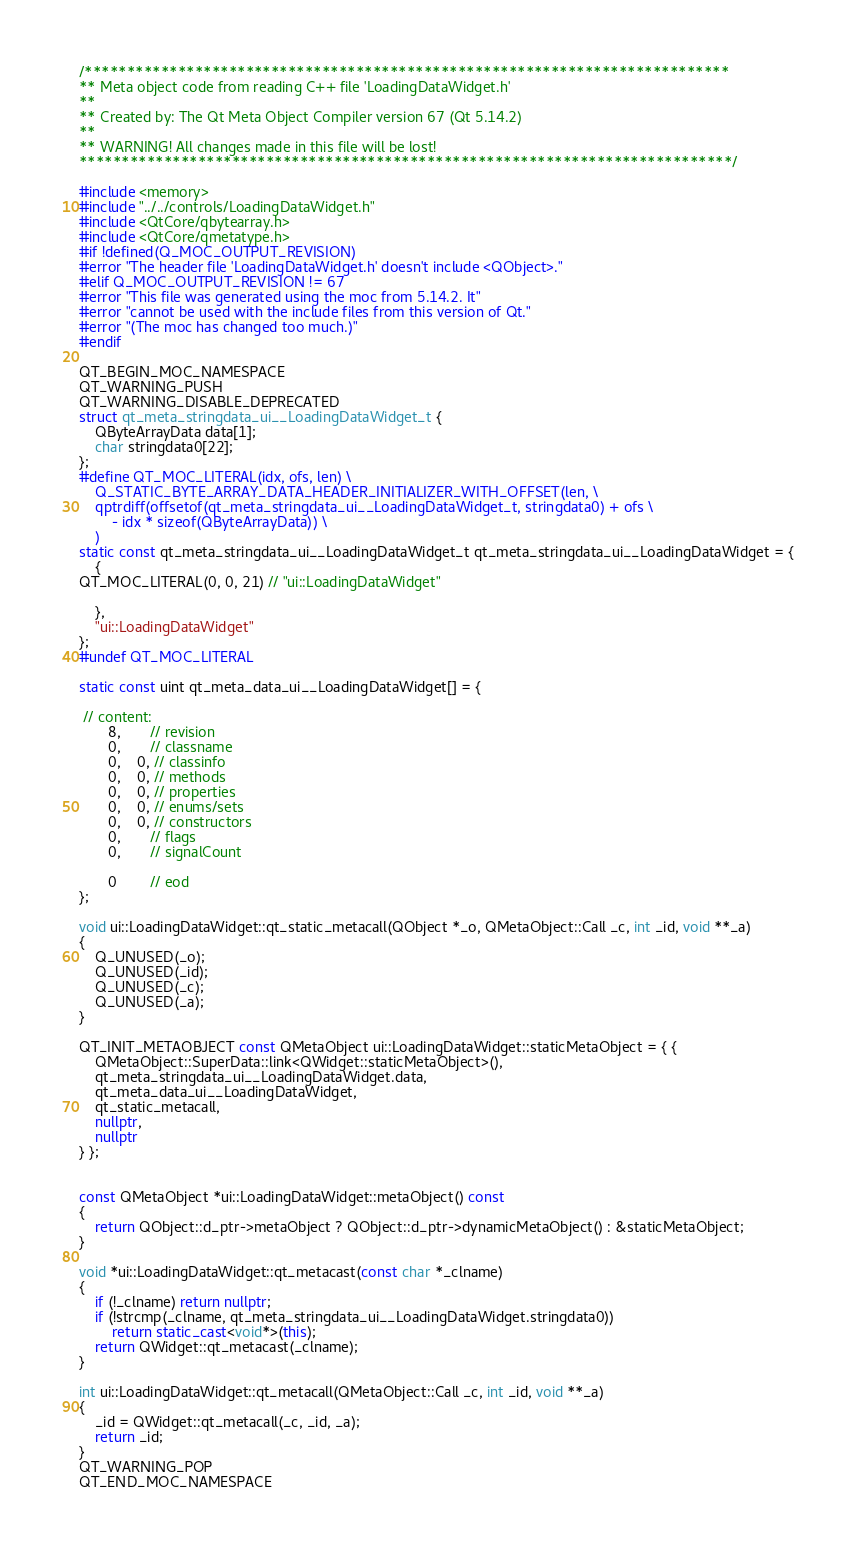Convert code to text. <code><loc_0><loc_0><loc_500><loc_500><_C++_>/****************************************************************************
** Meta object code from reading C++ file 'LoadingDataWidget.h'
**
** Created by: The Qt Meta Object Compiler version 67 (Qt 5.14.2)
**
** WARNING! All changes made in this file will be lost!
*****************************************************************************/

#include <memory>
#include "../../controls/LoadingDataWidget.h"
#include <QtCore/qbytearray.h>
#include <QtCore/qmetatype.h>
#if !defined(Q_MOC_OUTPUT_REVISION)
#error "The header file 'LoadingDataWidget.h' doesn't include <QObject>."
#elif Q_MOC_OUTPUT_REVISION != 67
#error "This file was generated using the moc from 5.14.2. It"
#error "cannot be used with the include files from this version of Qt."
#error "(The moc has changed too much.)"
#endif

QT_BEGIN_MOC_NAMESPACE
QT_WARNING_PUSH
QT_WARNING_DISABLE_DEPRECATED
struct qt_meta_stringdata_ui__LoadingDataWidget_t {
    QByteArrayData data[1];
    char stringdata0[22];
};
#define QT_MOC_LITERAL(idx, ofs, len) \
    Q_STATIC_BYTE_ARRAY_DATA_HEADER_INITIALIZER_WITH_OFFSET(len, \
    qptrdiff(offsetof(qt_meta_stringdata_ui__LoadingDataWidget_t, stringdata0) + ofs \
        - idx * sizeof(QByteArrayData)) \
    )
static const qt_meta_stringdata_ui__LoadingDataWidget_t qt_meta_stringdata_ui__LoadingDataWidget = {
    {
QT_MOC_LITERAL(0, 0, 21) // "ui::LoadingDataWidget"

    },
    "ui::LoadingDataWidget"
};
#undef QT_MOC_LITERAL

static const uint qt_meta_data_ui__LoadingDataWidget[] = {

 // content:
       8,       // revision
       0,       // classname
       0,    0, // classinfo
       0,    0, // methods
       0,    0, // properties
       0,    0, // enums/sets
       0,    0, // constructors
       0,       // flags
       0,       // signalCount

       0        // eod
};

void ui::LoadingDataWidget::qt_static_metacall(QObject *_o, QMetaObject::Call _c, int _id, void **_a)
{
    Q_UNUSED(_o);
    Q_UNUSED(_id);
    Q_UNUSED(_c);
    Q_UNUSED(_a);
}

QT_INIT_METAOBJECT const QMetaObject ui::LoadingDataWidget::staticMetaObject = { {
    QMetaObject::SuperData::link<QWidget::staticMetaObject>(),
    qt_meta_stringdata_ui__LoadingDataWidget.data,
    qt_meta_data_ui__LoadingDataWidget,
    qt_static_metacall,
    nullptr,
    nullptr
} };


const QMetaObject *ui::LoadingDataWidget::metaObject() const
{
    return QObject::d_ptr->metaObject ? QObject::d_ptr->dynamicMetaObject() : &staticMetaObject;
}

void *ui::LoadingDataWidget::qt_metacast(const char *_clname)
{
    if (!_clname) return nullptr;
    if (!strcmp(_clname, qt_meta_stringdata_ui__LoadingDataWidget.stringdata0))
        return static_cast<void*>(this);
    return QWidget::qt_metacast(_clname);
}

int ui::LoadingDataWidget::qt_metacall(QMetaObject::Call _c, int _id, void **_a)
{
    _id = QWidget::qt_metacall(_c, _id, _a);
    return _id;
}
QT_WARNING_POP
QT_END_MOC_NAMESPACE
</code> 